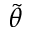<formula> <loc_0><loc_0><loc_500><loc_500>\tilde { \theta }</formula> 